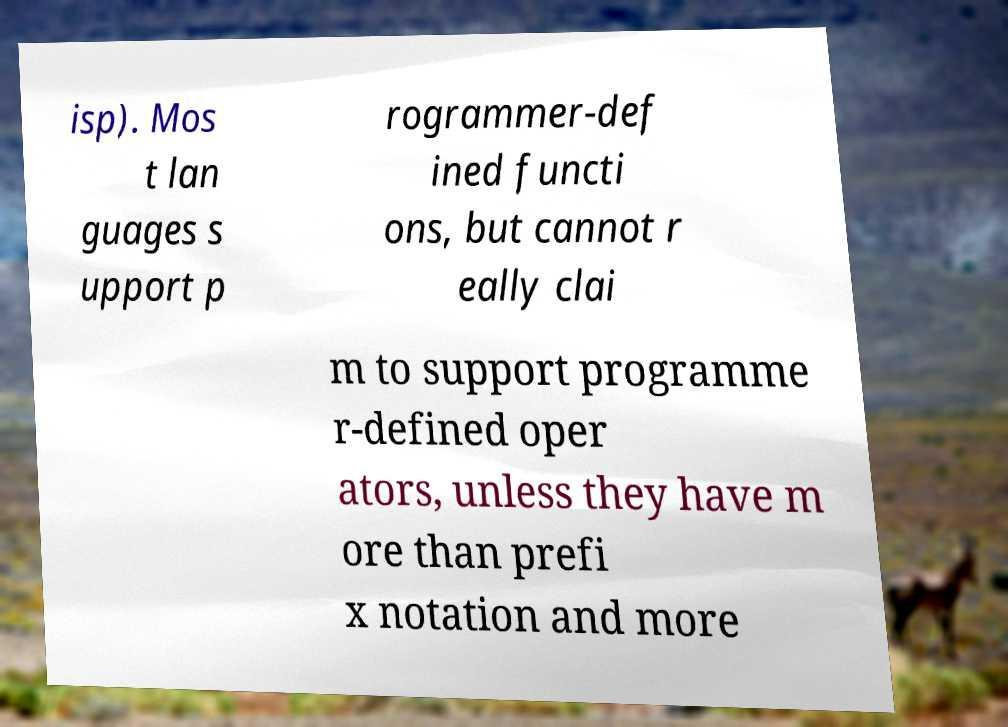Please identify and transcribe the text found in this image. isp). Mos t lan guages s upport p rogrammer-def ined functi ons, but cannot r eally clai m to support programme r-defined oper ators, unless they have m ore than prefi x notation and more 